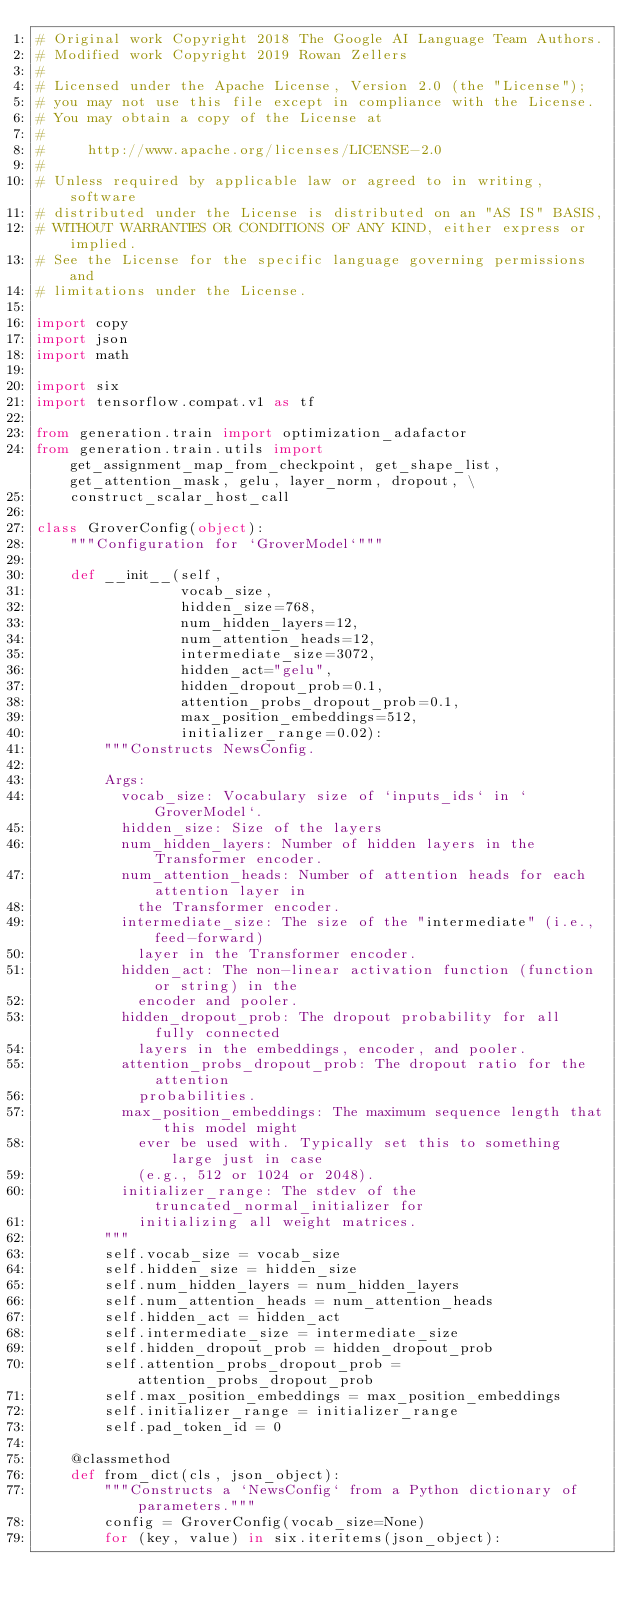<code> <loc_0><loc_0><loc_500><loc_500><_Python_># Original work Copyright 2018 The Google AI Language Team Authors.
# Modified work Copyright 2019 Rowan Zellers
#
# Licensed under the Apache License, Version 2.0 (the "License");
# you may not use this file except in compliance with the License.
# You may obtain a copy of the License at
#
#     http://www.apache.org/licenses/LICENSE-2.0
#
# Unless required by applicable law or agreed to in writing, software
# distributed under the License is distributed on an "AS IS" BASIS,
# WITHOUT WARRANTIES OR CONDITIONS OF ANY KIND, either express or implied.
# See the License for the specific language governing permissions and
# limitations under the License.

import copy
import json
import math

import six
import tensorflow.compat.v1 as tf

from generation.train import optimization_adafactor
from generation.train.utils import get_assignment_map_from_checkpoint, get_shape_list, get_attention_mask, gelu, layer_norm, dropout, \
    construct_scalar_host_call

class GroverConfig(object):
    """Configuration for `GroverModel`"""

    def __init__(self,
                 vocab_size,
                 hidden_size=768,
                 num_hidden_layers=12,
                 num_attention_heads=12,
                 intermediate_size=3072,
                 hidden_act="gelu",
                 hidden_dropout_prob=0.1,
                 attention_probs_dropout_prob=0.1,
                 max_position_embeddings=512,
                 initializer_range=0.02):
        """Constructs NewsConfig.

        Args:
          vocab_size: Vocabulary size of `inputs_ids` in `GroverModel`.
          hidden_size: Size of the layers
          num_hidden_layers: Number of hidden layers in the Transformer encoder.
          num_attention_heads: Number of attention heads for each attention layer in
            the Transformer encoder.
          intermediate_size: The size of the "intermediate" (i.e., feed-forward)
            layer in the Transformer encoder.
          hidden_act: The non-linear activation function (function or string) in the
            encoder and pooler.
          hidden_dropout_prob: The dropout probability for all fully connected
            layers in the embeddings, encoder, and pooler.
          attention_probs_dropout_prob: The dropout ratio for the attention
            probabilities.
          max_position_embeddings: The maximum sequence length that this model might
            ever be used with. Typically set this to something large just in case
            (e.g., 512 or 1024 or 2048).
          initializer_range: The stdev of the truncated_normal_initializer for
            initializing all weight matrices.
        """
        self.vocab_size = vocab_size
        self.hidden_size = hidden_size
        self.num_hidden_layers = num_hidden_layers
        self.num_attention_heads = num_attention_heads
        self.hidden_act = hidden_act
        self.intermediate_size = intermediate_size
        self.hidden_dropout_prob = hidden_dropout_prob
        self.attention_probs_dropout_prob = attention_probs_dropout_prob
        self.max_position_embeddings = max_position_embeddings
        self.initializer_range = initializer_range
        self.pad_token_id = 0

    @classmethod
    def from_dict(cls, json_object):
        """Constructs a `NewsConfig` from a Python dictionary of parameters."""
        config = GroverConfig(vocab_size=None)
        for (key, value) in six.iteritems(json_object):</code> 